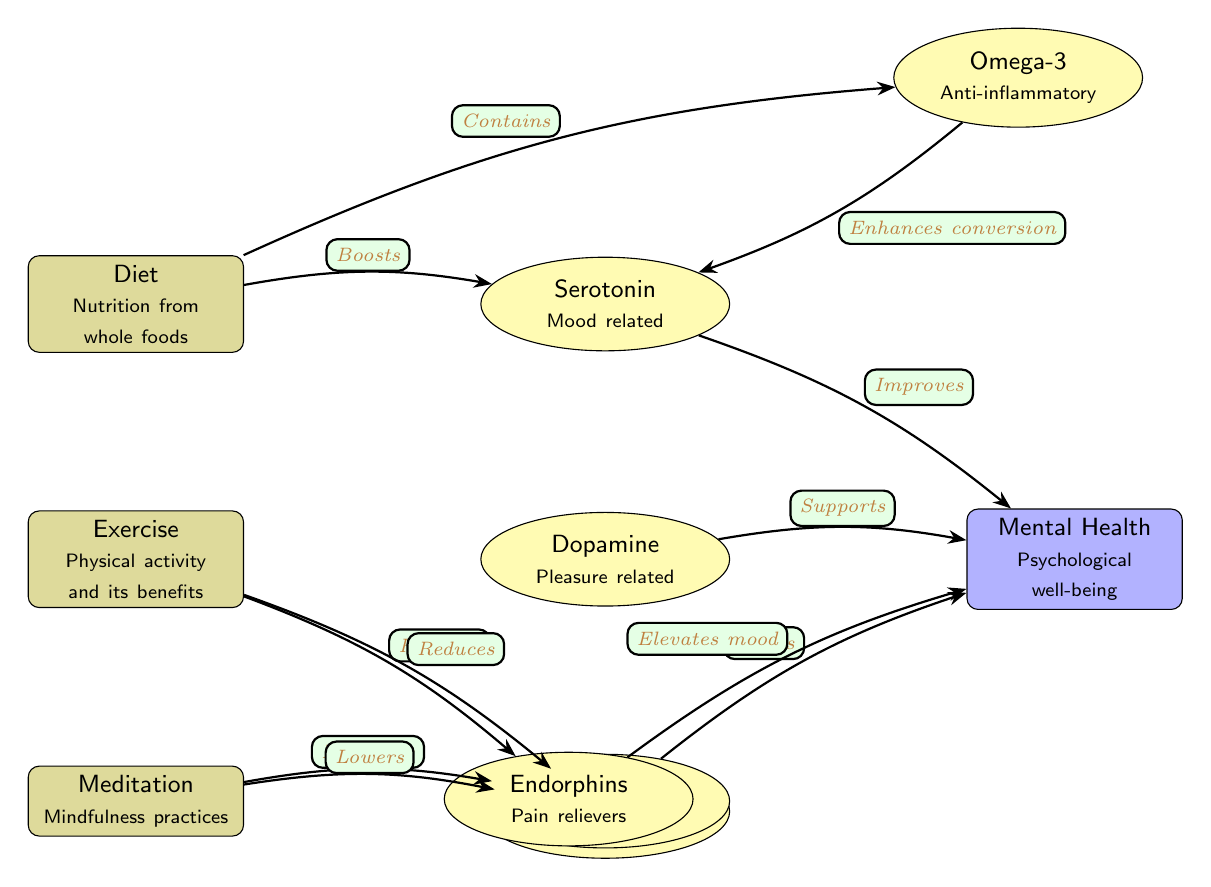What are the three holistic practices depicted in the diagram? The diagram lists diet, exercise, and meditation as the three holistic practices. Each practice is represented by a node and labeled accordingly.
Answer: Diet, Exercise, Meditation Which chemical is associated with exercise and pleasure? The diagram indicates that dopamine is the chemical related to exercise and pleasure, as it connects directly to the exercise node and is marked "Supports" for mental health.
Answer: Dopamine How many chemicals are shown in the diagram? By counting the chemical nodes present: serotonin, dopamine, cortisol, GABA, omega-3, and endorphins, we find there are six chemical nodes in total.
Answer: Six What effect does meditation have on cortisol? The diagram shows that meditation lowers cortisol, indicating a direct relationship between these two nodes.
Answer: Lowers Which chemical is indicated to enhance the conversion of serotonin? The diagram specifies that omega-3 enhances the conversion of serotonin, connecting it directly to the serotonin node with that description.
Answer: Omega-3 Which holistic practice boosts serotonin levels? The diagram indicates that the diet practice boosts serotonin, establishing a direct link as shown in the connection labeled "Boosts."
Answer: Diet What is the relationship between exercise and cortisol levels? The diagram states that exercise reduces cortisol, reflecting a positive connection whereby exercise can help manage stress levels.
Answer: Reduces Which chemical enhances relaxation according to the diagram? The diagram states that GABA is used for relaxation, which connects directly to the meditation practice that enhances this chemical.
Answer: GABA How does the release of endorphins affect mental health? The diagram illustrates that endorphins elevate mood, connecting this chemical to the mental health node, demonstrating a direct improvement in psychological well-being.
Answer: Elevates mood 